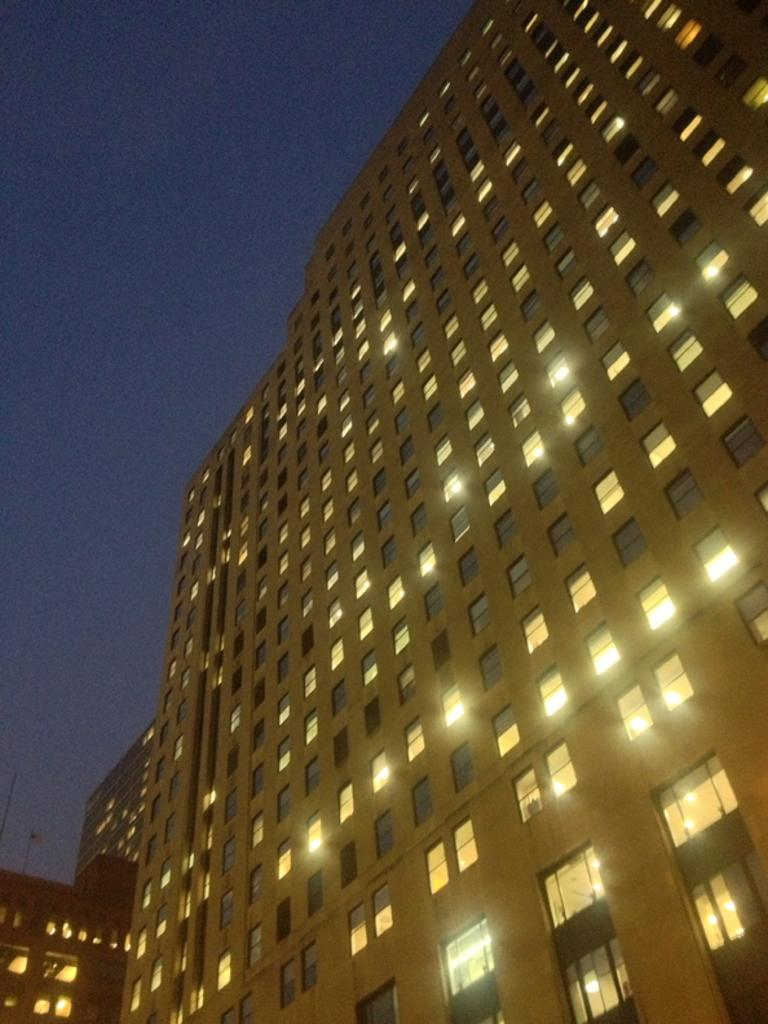What type of structures are present in the image? There are buildings in the image. What can be seen at the top of the image? The sky is visible at the top of the image. What features can be observed in the buildings? There are windows and lights visible in the buildings. Are there any glass elements in the buildings? Yes, there are glasses (possibly referring to glass windows or glass structures) in the buildings. Can you describe the journey of the bee in the image? There are no bees present in the image, so it is not possible to describe a journey for a bee. 